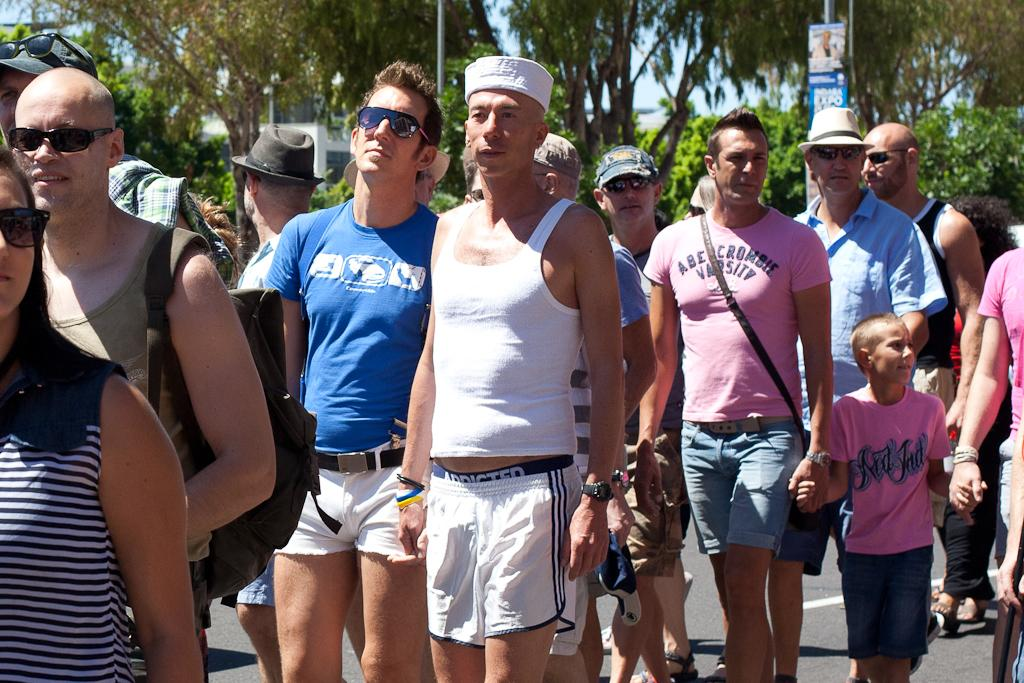<image>
Offer a succinct explanation of the picture presented. A line of people including a man in a pink shirt that says Abercrombie Varsity. 